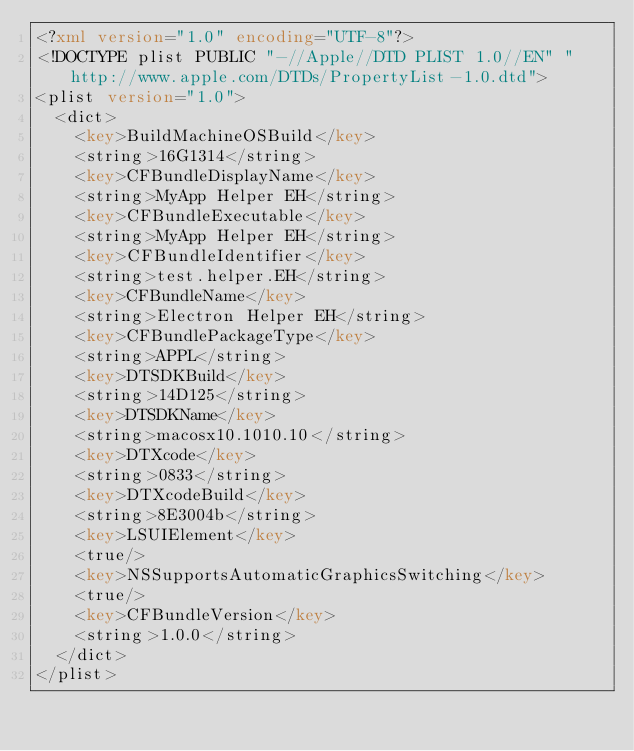<code> <loc_0><loc_0><loc_500><loc_500><_XML_><?xml version="1.0" encoding="UTF-8"?>
<!DOCTYPE plist PUBLIC "-//Apple//DTD PLIST 1.0//EN" "http://www.apple.com/DTDs/PropertyList-1.0.dtd">
<plist version="1.0">
  <dict>
    <key>BuildMachineOSBuild</key>
    <string>16G1314</string>
    <key>CFBundleDisplayName</key>
    <string>MyApp Helper EH</string>
    <key>CFBundleExecutable</key>
    <string>MyApp Helper EH</string>
    <key>CFBundleIdentifier</key>
    <string>test.helper.EH</string>
    <key>CFBundleName</key>
    <string>Electron Helper EH</string>
    <key>CFBundlePackageType</key>
    <string>APPL</string>
    <key>DTSDKBuild</key>
    <string>14D125</string>
    <key>DTSDKName</key>
    <string>macosx10.1010.10</string>
    <key>DTXcode</key>
    <string>0833</string>
    <key>DTXcodeBuild</key>
    <string>8E3004b</string>
    <key>LSUIElement</key>
    <true/>
    <key>NSSupportsAutomaticGraphicsSwitching</key>
    <true/>
    <key>CFBundleVersion</key>
    <string>1.0.0</string>
  </dict>
</plist></code> 